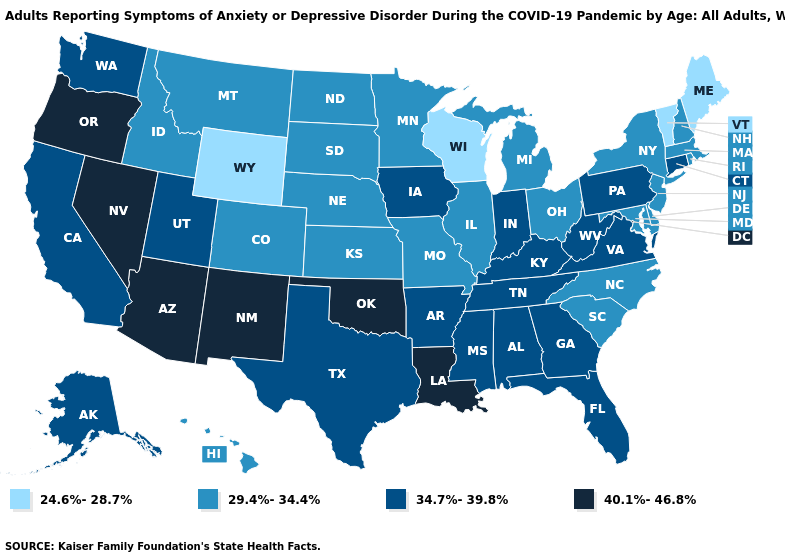What is the highest value in the USA?
Keep it brief. 40.1%-46.8%. Does New York have the same value as Arkansas?
Give a very brief answer. No. How many symbols are there in the legend?
Write a very short answer. 4. What is the highest value in states that border Arkansas?
Quick response, please. 40.1%-46.8%. How many symbols are there in the legend?
Be succinct. 4. What is the value of South Carolina?
Short answer required. 29.4%-34.4%. Name the states that have a value in the range 40.1%-46.8%?
Give a very brief answer. Arizona, Louisiana, Nevada, New Mexico, Oklahoma, Oregon. Name the states that have a value in the range 24.6%-28.7%?
Quick response, please. Maine, Vermont, Wisconsin, Wyoming. Name the states that have a value in the range 24.6%-28.7%?
Be succinct. Maine, Vermont, Wisconsin, Wyoming. Does Ohio have the same value as North Dakota?
Answer briefly. Yes. Which states hav the highest value in the MidWest?
Write a very short answer. Indiana, Iowa. Does Connecticut have a higher value than Arizona?
Be succinct. No. What is the value of Mississippi?
Quick response, please. 34.7%-39.8%. Does Wyoming have a higher value than Nebraska?
Write a very short answer. No. What is the lowest value in the South?
Write a very short answer. 29.4%-34.4%. 